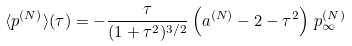<formula> <loc_0><loc_0><loc_500><loc_500>\langle p ^ { ( N ) } \rangle ( \tau ) = - \frac { \tau } { ( 1 + \tau ^ { 2 } ) ^ { 3 / 2 } } \left ( a ^ { ( N ) } - 2 - \tau ^ { 2 } \right ) \, p _ { \infty } ^ { ( N ) }</formula> 